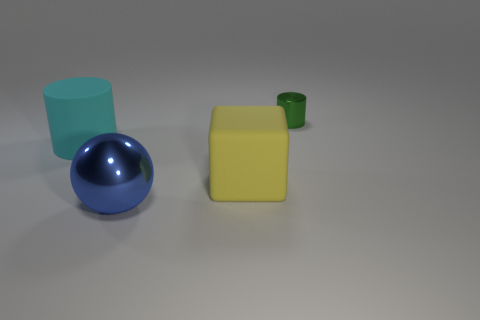What is the material of the large object that is right of the metallic thing that is left of the object on the right side of the yellow rubber block?
Give a very brief answer. Rubber. The big thing that is right of the big blue metallic thing is what color?
Provide a succinct answer. Yellow. Is there anything else that has the same shape as the large shiny object?
Give a very brief answer. No. There is a cylinder left of the metal object right of the blue metal ball; what is its size?
Keep it short and to the point. Large. Are there an equal number of metallic balls in front of the big ball and cyan matte cylinders on the left side of the cyan cylinder?
Ensure brevity in your answer.  Yes. Is there any other thing that is the same size as the green shiny object?
Your response must be concise. No. What color is the small object that is the same material as the large ball?
Your response must be concise. Green. Is the large cyan thing made of the same material as the big thing on the right side of the big blue sphere?
Your response must be concise. Yes. The object that is behind the yellow matte object and right of the cyan rubber thing is what color?
Keep it short and to the point. Green. What number of balls are tiny brown metallic objects or cyan objects?
Offer a terse response. 0. 